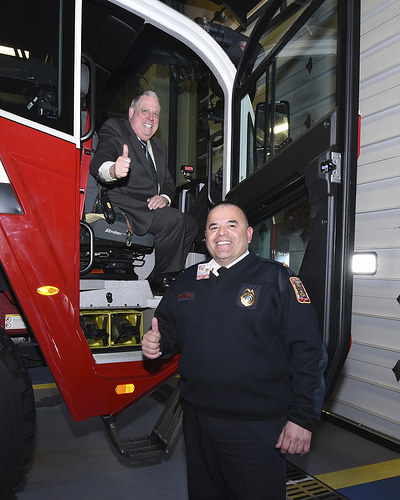<image>
Can you confirm if the driver is behind the fireman? Yes. From this viewpoint, the driver is positioned behind the fireman, with the fireman partially or fully occluding the driver. 